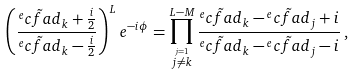Convert formula to latex. <formula><loc_0><loc_0><loc_500><loc_500>\left ( \frac { \tilde { ^ { e } c f a d } _ { k } + \frac { i } { 2 } } { \tilde { ^ { e } c f a d } _ { k } - \frac { i } { 2 } } \right ) ^ { L } e ^ { - i \phi } = \prod _ { \stackrel { j = 1 } { j \neq k } } ^ { L - M } \frac { \tilde { ^ { e } c f a d } _ { k } - \tilde { ^ { e } c f a d } _ { j } + i } { \tilde { ^ { e } c f a d } _ { k } - \tilde { ^ { e } c f a d } _ { j } - i } \, ,</formula> 